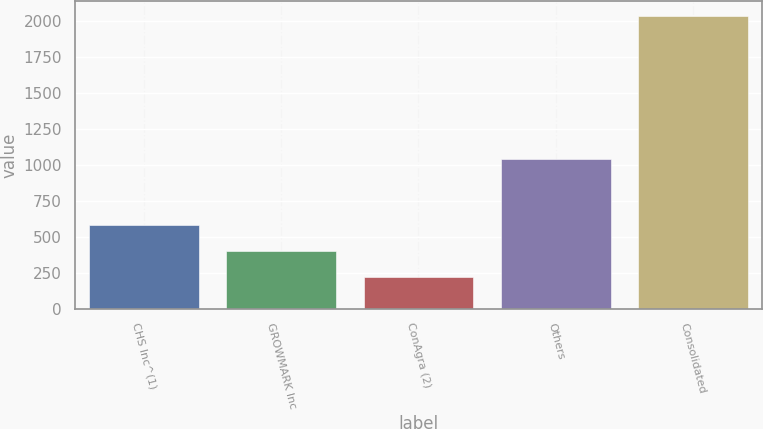Convert chart to OTSL. <chart><loc_0><loc_0><loc_500><loc_500><bar_chart><fcel>CHS Inc^(1)<fcel>GROWMARK Inc<fcel>ConAgra (2)<fcel>Others<fcel>Consolidated<nl><fcel>583.62<fcel>402.46<fcel>221.3<fcel>1042.5<fcel>2032.9<nl></chart> 